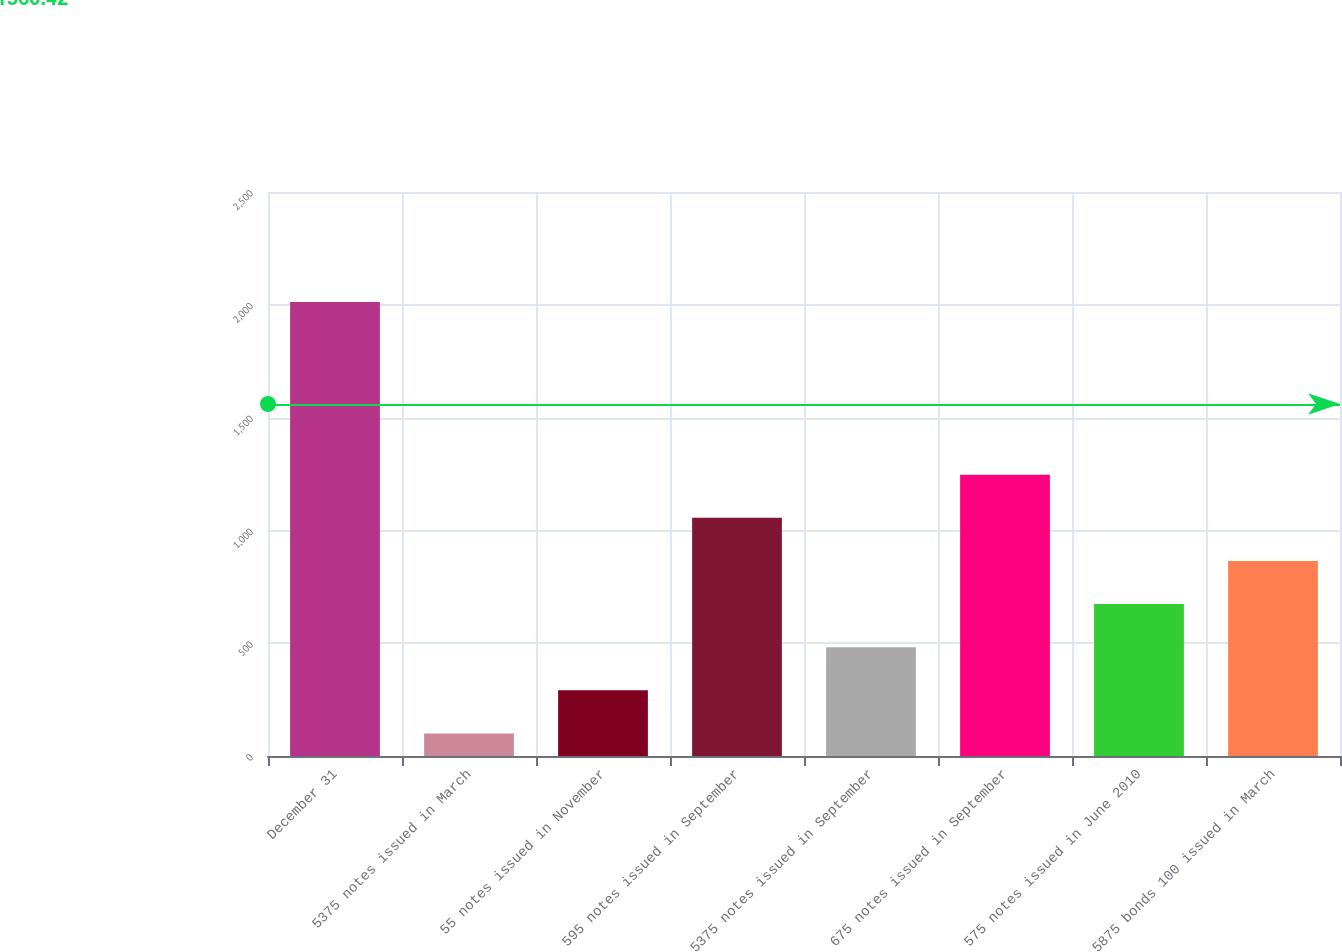Convert chart to OTSL. <chart><loc_0><loc_0><loc_500><loc_500><bar_chart><fcel>December 31<fcel>5375 notes issued in March<fcel>55 notes issued in November<fcel>595 notes issued in September<fcel>5375 notes issued in September<fcel>675 notes issued in September<fcel>575 notes issued in June 2010<fcel>5875 bonds 100 issued in March<nl><fcel>2012<fcel>100<fcel>291.2<fcel>1056<fcel>482.4<fcel>1247.2<fcel>673.6<fcel>864.8<nl></chart> 